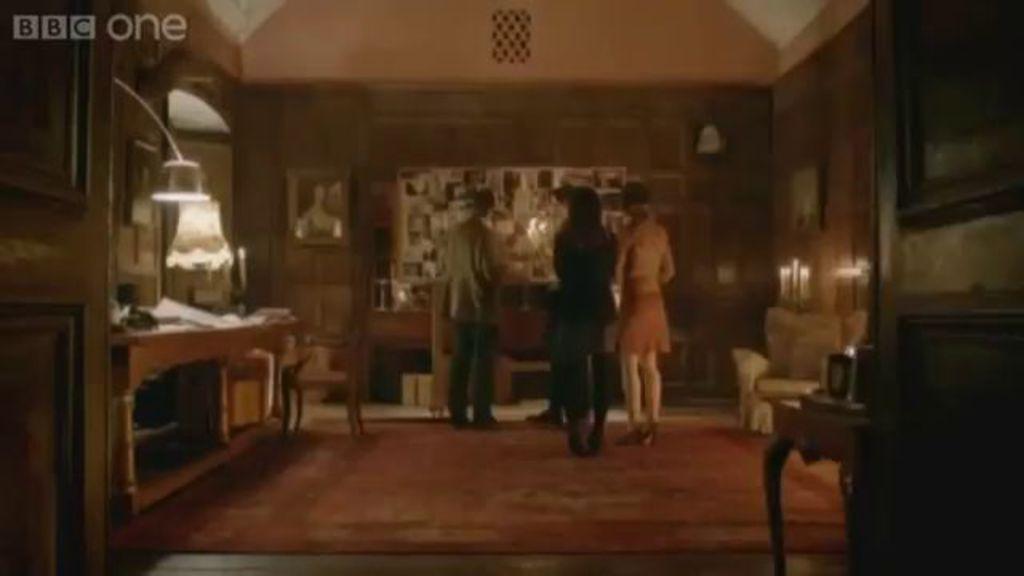Please provide a concise description of this image. Here we can see three persons are standing on the floor. This is table. On the table there are papers. There is a chair. In the background there is a wall and these are the frames. This is floor and this is door. 